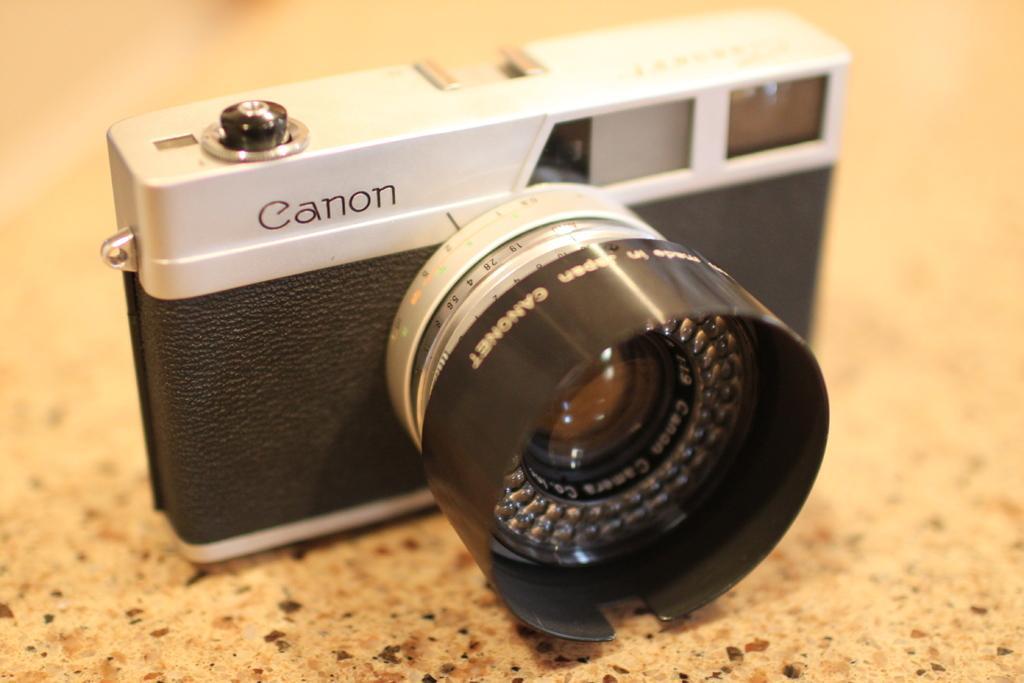Can you describe this image briefly? In this image there is a camera on the floor, there is text on the camera, there are numbers on the camera, the background of the image is blurred. 